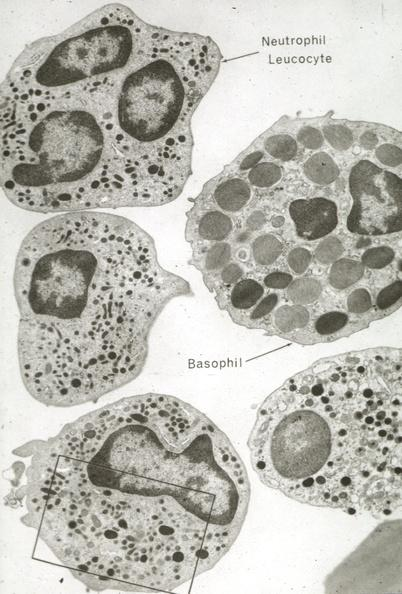does this image show neutrophils and basophil?
Answer the question using a single word or phrase. Yes 